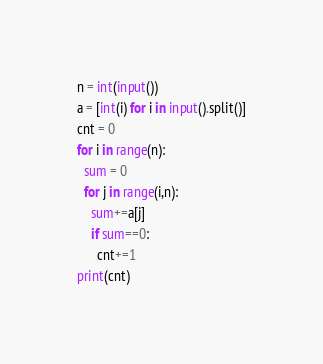Convert code to text. <code><loc_0><loc_0><loc_500><loc_500><_Python_>n = int(input())
a = [int(i) for i in input().split()]
cnt = 0
for i in range(n):
  sum = 0
  for j in range(i,n):
    sum+=a[j]
    if sum==0:
      cnt+=1
print(cnt)</code> 